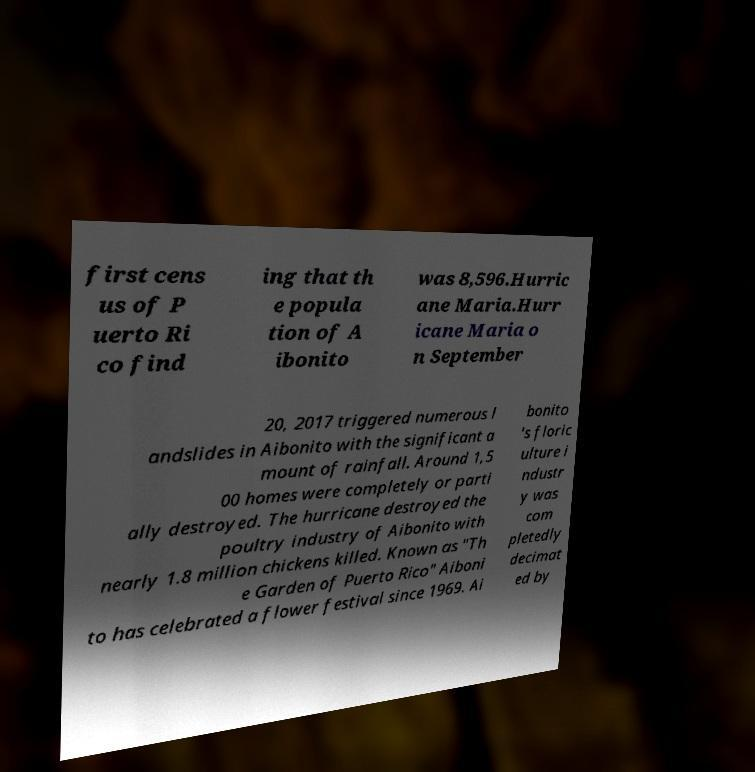Please identify and transcribe the text found in this image. first cens us of P uerto Ri co find ing that th e popula tion of A ibonito was 8,596.Hurric ane Maria.Hurr icane Maria o n September 20, 2017 triggered numerous l andslides in Aibonito with the significant a mount of rainfall. Around 1,5 00 homes were completely or parti ally destroyed. The hurricane destroyed the poultry industry of Aibonito with nearly 1.8 million chickens killed. Known as "Th e Garden of Puerto Rico" Aiboni to has celebrated a flower festival since 1969. Ai bonito 's floric ulture i ndustr y was com pletedly decimat ed by 